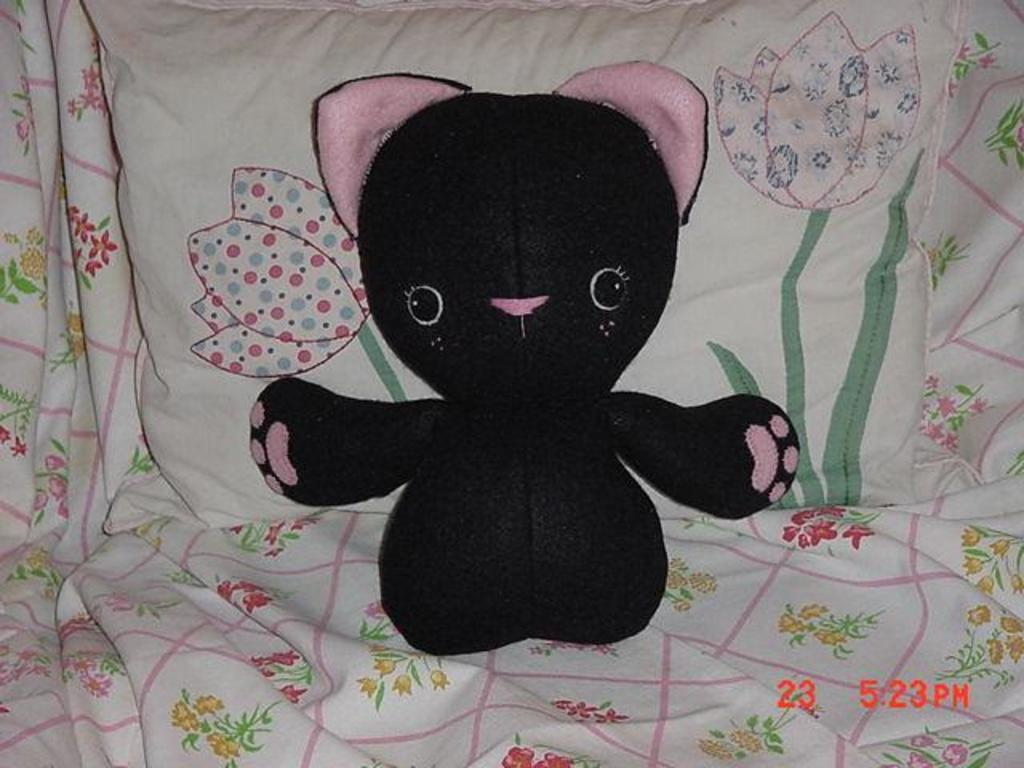What is the main object in the center of the image? There is a toy in the center of the image. What items are located at the bottom of the image? There is a blanket and a pillow at the bottom of the image. Is there any text present in the image? Yes, there is text at the bottom of the image. What type of quartz can be seen in the image? There is no quartz present in the image. What offer is being made in the image? There is no offer being made in the image. 